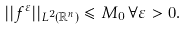<formula> <loc_0><loc_0><loc_500><loc_500>| | f ^ { \varepsilon } | | _ { L ^ { 2 } ( \mathbb { R } ^ { n } ) } \leqslant M _ { 0 } \, \forall \varepsilon > 0 .</formula> 